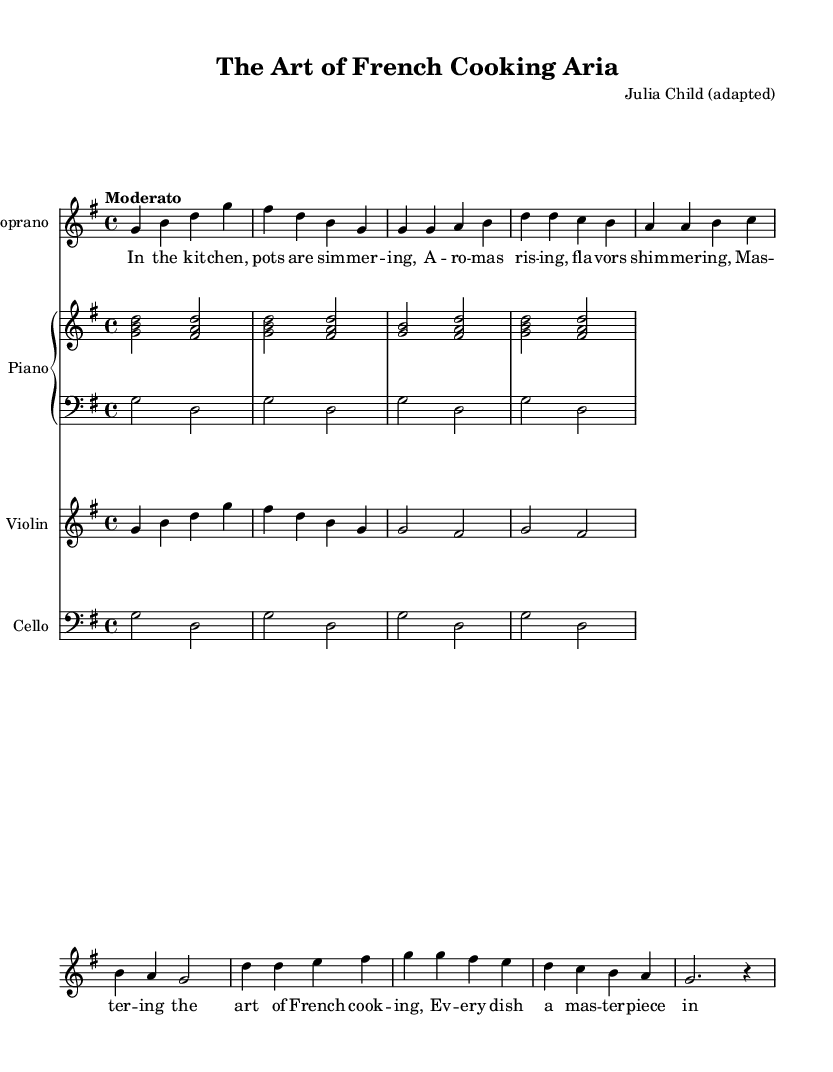What is the key signature of this music? The key signature is G major, which contains one sharp. This can be identified by looking at the beginning of the sheet music where the key signature is indicated.
Answer: G major What is the time signature of this music? The time signature is 4/4. This is visible at the beginning of the score, where the time signature is notated, indicating that there are four beats in each measure.
Answer: 4/4 What is the tempo marking of this piece? The tempo marking is "Moderato," which indicates that the music should be played at a moderate speed. This is found at the beginning of the score right after the time signature.
Answer: Moderato How many measures are in the soprano section? There are 8 measures in the soprano section, which can be counted by looking at the bar lines separating the melody notation.
Answer: 8 What is the primary theme of the lyrics in the chorus? The primary theme of the lyrics in the chorus is about mastering the art of cooking. Analyzing the repeated phrases in the chorus reveals that the focus is on culinary mastery.
Answer: Mastering the art of French cooking Which instrument has a simplified part in this score? The piano has a simplified part, as seen in the arrangement where the upper and lower staffs indicate a less complex accompaniment. This is evident from the reduced complexity of the notes notated for the performing musician.
Answer: Piano 